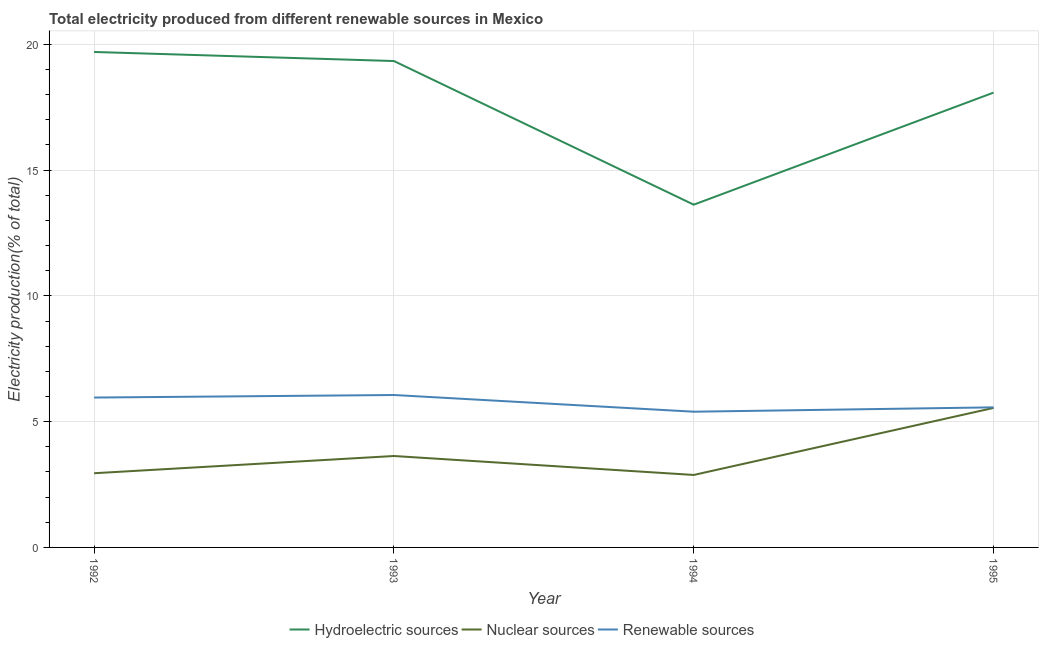Does the line corresponding to percentage of electricity produced by nuclear sources intersect with the line corresponding to percentage of electricity produced by hydroelectric sources?
Make the answer very short. No. What is the percentage of electricity produced by nuclear sources in 1994?
Make the answer very short. 2.88. Across all years, what is the maximum percentage of electricity produced by nuclear sources?
Your answer should be compact. 5.55. Across all years, what is the minimum percentage of electricity produced by nuclear sources?
Your answer should be compact. 2.88. In which year was the percentage of electricity produced by renewable sources minimum?
Make the answer very short. 1994. What is the total percentage of electricity produced by renewable sources in the graph?
Offer a very short reply. 22.98. What is the difference between the percentage of electricity produced by nuclear sources in 1992 and that in 1993?
Provide a short and direct response. -0.68. What is the difference between the percentage of electricity produced by nuclear sources in 1992 and the percentage of electricity produced by renewable sources in 1993?
Ensure brevity in your answer.  -3.11. What is the average percentage of electricity produced by hydroelectric sources per year?
Offer a very short reply. 17.69. In the year 1994, what is the difference between the percentage of electricity produced by renewable sources and percentage of electricity produced by hydroelectric sources?
Make the answer very short. -8.23. What is the ratio of the percentage of electricity produced by hydroelectric sources in 1992 to that in 1994?
Your answer should be very brief. 1.45. What is the difference between the highest and the second highest percentage of electricity produced by renewable sources?
Offer a very short reply. 0.1. What is the difference between the highest and the lowest percentage of electricity produced by hydroelectric sources?
Your answer should be very brief. 6.07. Is the sum of the percentage of electricity produced by nuclear sources in 1994 and 1995 greater than the maximum percentage of electricity produced by hydroelectric sources across all years?
Make the answer very short. No. Is it the case that in every year, the sum of the percentage of electricity produced by hydroelectric sources and percentage of electricity produced by nuclear sources is greater than the percentage of electricity produced by renewable sources?
Your answer should be compact. Yes. How many lines are there?
Ensure brevity in your answer.  3. How many years are there in the graph?
Provide a short and direct response. 4. What is the difference between two consecutive major ticks on the Y-axis?
Offer a very short reply. 5. Are the values on the major ticks of Y-axis written in scientific E-notation?
Give a very brief answer. No. Does the graph contain any zero values?
Provide a short and direct response. No. Does the graph contain grids?
Your answer should be compact. Yes. Where does the legend appear in the graph?
Offer a very short reply. Bottom center. How are the legend labels stacked?
Provide a short and direct response. Horizontal. What is the title of the graph?
Your answer should be compact. Total electricity produced from different renewable sources in Mexico. Does "Ages 20-60" appear as one of the legend labels in the graph?
Offer a very short reply. No. What is the Electricity production(% of total) in Hydroelectric sources in 1992?
Offer a very short reply. 19.7. What is the Electricity production(% of total) of Nuclear sources in 1992?
Make the answer very short. 2.95. What is the Electricity production(% of total) in Renewable sources in 1992?
Ensure brevity in your answer.  5.96. What is the Electricity production(% of total) of Hydroelectric sources in 1993?
Your response must be concise. 19.34. What is the Electricity production(% of total) of Nuclear sources in 1993?
Offer a terse response. 3.63. What is the Electricity production(% of total) of Renewable sources in 1993?
Keep it short and to the point. 6.06. What is the Electricity production(% of total) in Hydroelectric sources in 1994?
Provide a succinct answer. 13.63. What is the Electricity production(% of total) in Nuclear sources in 1994?
Make the answer very short. 2.88. What is the Electricity production(% of total) in Renewable sources in 1994?
Ensure brevity in your answer.  5.4. What is the Electricity production(% of total) in Hydroelectric sources in 1995?
Offer a very short reply. 18.08. What is the Electricity production(% of total) of Nuclear sources in 1995?
Offer a terse response. 5.55. What is the Electricity production(% of total) in Renewable sources in 1995?
Provide a succinct answer. 5.57. Across all years, what is the maximum Electricity production(% of total) of Hydroelectric sources?
Give a very brief answer. 19.7. Across all years, what is the maximum Electricity production(% of total) of Nuclear sources?
Your answer should be compact. 5.55. Across all years, what is the maximum Electricity production(% of total) of Renewable sources?
Provide a short and direct response. 6.06. Across all years, what is the minimum Electricity production(% of total) of Hydroelectric sources?
Your answer should be compact. 13.63. Across all years, what is the minimum Electricity production(% of total) in Nuclear sources?
Keep it short and to the point. 2.88. Across all years, what is the minimum Electricity production(% of total) of Renewable sources?
Your answer should be very brief. 5.4. What is the total Electricity production(% of total) in Hydroelectric sources in the graph?
Provide a short and direct response. 70.74. What is the total Electricity production(% of total) of Nuclear sources in the graph?
Provide a short and direct response. 15.01. What is the total Electricity production(% of total) in Renewable sources in the graph?
Offer a terse response. 22.98. What is the difference between the Electricity production(% of total) in Hydroelectric sources in 1992 and that in 1993?
Provide a succinct answer. 0.36. What is the difference between the Electricity production(% of total) in Nuclear sources in 1992 and that in 1993?
Provide a succinct answer. -0.68. What is the difference between the Electricity production(% of total) in Renewable sources in 1992 and that in 1993?
Provide a succinct answer. -0.1. What is the difference between the Electricity production(% of total) of Hydroelectric sources in 1992 and that in 1994?
Offer a very short reply. 6.07. What is the difference between the Electricity production(% of total) in Nuclear sources in 1992 and that in 1994?
Provide a succinct answer. 0.07. What is the difference between the Electricity production(% of total) of Renewable sources in 1992 and that in 1994?
Your response must be concise. 0.56. What is the difference between the Electricity production(% of total) in Hydroelectric sources in 1992 and that in 1995?
Offer a terse response. 1.62. What is the difference between the Electricity production(% of total) in Nuclear sources in 1992 and that in 1995?
Give a very brief answer. -2.6. What is the difference between the Electricity production(% of total) in Renewable sources in 1992 and that in 1995?
Your response must be concise. 0.39. What is the difference between the Electricity production(% of total) of Hydroelectric sources in 1993 and that in 1994?
Your answer should be very brief. 5.71. What is the difference between the Electricity production(% of total) in Nuclear sources in 1993 and that in 1994?
Your response must be concise. 0.75. What is the difference between the Electricity production(% of total) of Renewable sources in 1993 and that in 1994?
Ensure brevity in your answer.  0.66. What is the difference between the Electricity production(% of total) in Hydroelectric sources in 1993 and that in 1995?
Your answer should be compact. 1.26. What is the difference between the Electricity production(% of total) in Nuclear sources in 1993 and that in 1995?
Keep it short and to the point. -1.91. What is the difference between the Electricity production(% of total) in Renewable sources in 1993 and that in 1995?
Keep it short and to the point. 0.49. What is the difference between the Electricity production(% of total) in Hydroelectric sources in 1994 and that in 1995?
Provide a short and direct response. -4.46. What is the difference between the Electricity production(% of total) in Nuclear sources in 1994 and that in 1995?
Provide a succinct answer. -2.66. What is the difference between the Electricity production(% of total) of Renewable sources in 1994 and that in 1995?
Your answer should be very brief. -0.17. What is the difference between the Electricity production(% of total) of Hydroelectric sources in 1992 and the Electricity production(% of total) of Nuclear sources in 1993?
Your answer should be very brief. 16.06. What is the difference between the Electricity production(% of total) of Hydroelectric sources in 1992 and the Electricity production(% of total) of Renewable sources in 1993?
Provide a short and direct response. 13.64. What is the difference between the Electricity production(% of total) of Nuclear sources in 1992 and the Electricity production(% of total) of Renewable sources in 1993?
Give a very brief answer. -3.11. What is the difference between the Electricity production(% of total) of Hydroelectric sources in 1992 and the Electricity production(% of total) of Nuclear sources in 1994?
Give a very brief answer. 16.82. What is the difference between the Electricity production(% of total) of Hydroelectric sources in 1992 and the Electricity production(% of total) of Renewable sources in 1994?
Give a very brief answer. 14.3. What is the difference between the Electricity production(% of total) of Nuclear sources in 1992 and the Electricity production(% of total) of Renewable sources in 1994?
Ensure brevity in your answer.  -2.45. What is the difference between the Electricity production(% of total) of Hydroelectric sources in 1992 and the Electricity production(% of total) of Nuclear sources in 1995?
Ensure brevity in your answer.  14.15. What is the difference between the Electricity production(% of total) in Hydroelectric sources in 1992 and the Electricity production(% of total) in Renewable sources in 1995?
Your response must be concise. 14.13. What is the difference between the Electricity production(% of total) of Nuclear sources in 1992 and the Electricity production(% of total) of Renewable sources in 1995?
Offer a very short reply. -2.62. What is the difference between the Electricity production(% of total) of Hydroelectric sources in 1993 and the Electricity production(% of total) of Nuclear sources in 1994?
Your response must be concise. 16.46. What is the difference between the Electricity production(% of total) in Hydroelectric sources in 1993 and the Electricity production(% of total) in Renewable sources in 1994?
Give a very brief answer. 13.94. What is the difference between the Electricity production(% of total) of Nuclear sources in 1993 and the Electricity production(% of total) of Renewable sources in 1994?
Ensure brevity in your answer.  -1.76. What is the difference between the Electricity production(% of total) of Hydroelectric sources in 1993 and the Electricity production(% of total) of Nuclear sources in 1995?
Provide a succinct answer. 13.79. What is the difference between the Electricity production(% of total) of Hydroelectric sources in 1993 and the Electricity production(% of total) of Renewable sources in 1995?
Provide a short and direct response. 13.77. What is the difference between the Electricity production(% of total) in Nuclear sources in 1993 and the Electricity production(% of total) in Renewable sources in 1995?
Make the answer very short. -1.93. What is the difference between the Electricity production(% of total) of Hydroelectric sources in 1994 and the Electricity production(% of total) of Nuclear sources in 1995?
Your answer should be very brief. 8.08. What is the difference between the Electricity production(% of total) in Hydroelectric sources in 1994 and the Electricity production(% of total) in Renewable sources in 1995?
Ensure brevity in your answer.  8.06. What is the difference between the Electricity production(% of total) in Nuclear sources in 1994 and the Electricity production(% of total) in Renewable sources in 1995?
Offer a very short reply. -2.69. What is the average Electricity production(% of total) in Hydroelectric sources per year?
Give a very brief answer. 17.69. What is the average Electricity production(% of total) in Nuclear sources per year?
Keep it short and to the point. 3.75. What is the average Electricity production(% of total) of Renewable sources per year?
Give a very brief answer. 5.75. In the year 1992, what is the difference between the Electricity production(% of total) of Hydroelectric sources and Electricity production(% of total) of Nuclear sources?
Keep it short and to the point. 16.75. In the year 1992, what is the difference between the Electricity production(% of total) of Hydroelectric sources and Electricity production(% of total) of Renewable sources?
Offer a terse response. 13.74. In the year 1992, what is the difference between the Electricity production(% of total) of Nuclear sources and Electricity production(% of total) of Renewable sources?
Offer a very short reply. -3.01. In the year 1993, what is the difference between the Electricity production(% of total) in Hydroelectric sources and Electricity production(% of total) in Nuclear sources?
Offer a terse response. 15.7. In the year 1993, what is the difference between the Electricity production(% of total) in Hydroelectric sources and Electricity production(% of total) in Renewable sources?
Ensure brevity in your answer.  13.28. In the year 1993, what is the difference between the Electricity production(% of total) in Nuclear sources and Electricity production(% of total) in Renewable sources?
Your answer should be very brief. -2.42. In the year 1994, what is the difference between the Electricity production(% of total) in Hydroelectric sources and Electricity production(% of total) in Nuclear sources?
Your answer should be very brief. 10.74. In the year 1994, what is the difference between the Electricity production(% of total) in Hydroelectric sources and Electricity production(% of total) in Renewable sources?
Keep it short and to the point. 8.23. In the year 1994, what is the difference between the Electricity production(% of total) in Nuclear sources and Electricity production(% of total) in Renewable sources?
Ensure brevity in your answer.  -2.51. In the year 1995, what is the difference between the Electricity production(% of total) of Hydroelectric sources and Electricity production(% of total) of Nuclear sources?
Make the answer very short. 12.54. In the year 1995, what is the difference between the Electricity production(% of total) of Hydroelectric sources and Electricity production(% of total) of Renewable sources?
Your response must be concise. 12.51. In the year 1995, what is the difference between the Electricity production(% of total) of Nuclear sources and Electricity production(% of total) of Renewable sources?
Keep it short and to the point. -0.02. What is the ratio of the Electricity production(% of total) of Hydroelectric sources in 1992 to that in 1993?
Give a very brief answer. 1.02. What is the ratio of the Electricity production(% of total) in Nuclear sources in 1992 to that in 1993?
Ensure brevity in your answer.  0.81. What is the ratio of the Electricity production(% of total) in Renewable sources in 1992 to that in 1993?
Your answer should be very brief. 0.98. What is the ratio of the Electricity production(% of total) in Hydroelectric sources in 1992 to that in 1994?
Keep it short and to the point. 1.45. What is the ratio of the Electricity production(% of total) in Nuclear sources in 1992 to that in 1994?
Offer a very short reply. 1.02. What is the ratio of the Electricity production(% of total) in Renewable sources in 1992 to that in 1994?
Keep it short and to the point. 1.1. What is the ratio of the Electricity production(% of total) of Hydroelectric sources in 1992 to that in 1995?
Ensure brevity in your answer.  1.09. What is the ratio of the Electricity production(% of total) in Nuclear sources in 1992 to that in 1995?
Keep it short and to the point. 0.53. What is the ratio of the Electricity production(% of total) in Renewable sources in 1992 to that in 1995?
Your answer should be compact. 1.07. What is the ratio of the Electricity production(% of total) in Hydroelectric sources in 1993 to that in 1994?
Keep it short and to the point. 1.42. What is the ratio of the Electricity production(% of total) of Nuclear sources in 1993 to that in 1994?
Make the answer very short. 1.26. What is the ratio of the Electricity production(% of total) in Renewable sources in 1993 to that in 1994?
Keep it short and to the point. 1.12. What is the ratio of the Electricity production(% of total) of Hydroelectric sources in 1993 to that in 1995?
Keep it short and to the point. 1.07. What is the ratio of the Electricity production(% of total) of Nuclear sources in 1993 to that in 1995?
Make the answer very short. 0.66. What is the ratio of the Electricity production(% of total) of Renewable sources in 1993 to that in 1995?
Offer a terse response. 1.09. What is the ratio of the Electricity production(% of total) of Hydroelectric sources in 1994 to that in 1995?
Ensure brevity in your answer.  0.75. What is the ratio of the Electricity production(% of total) of Nuclear sources in 1994 to that in 1995?
Your answer should be very brief. 0.52. What is the ratio of the Electricity production(% of total) of Renewable sources in 1994 to that in 1995?
Offer a terse response. 0.97. What is the difference between the highest and the second highest Electricity production(% of total) in Hydroelectric sources?
Give a very brief answer. 0.36. What is the difference between the highest and the second highest Electricity production(% of total) of Nuclear sources?
Make the answer very short. 1.91. What is the difference between the highest and the second highest Electricity production(% of total) of Renewable sources?
Your response must be concise. 0.1. What is the difference between the highest and the lowest Electricity production(% of total) in Hydroelectric sources?
Make the answer very short. 6.07. What is the difference between the highest and the lowest Electricity production(% of total) of Nuclear sources?
Provide a short and direct response. 2.66. What is the difference between the highest and the lowest Electricity production(% of total) in Renewable sources?
Give a very brief answer. 0.66. 